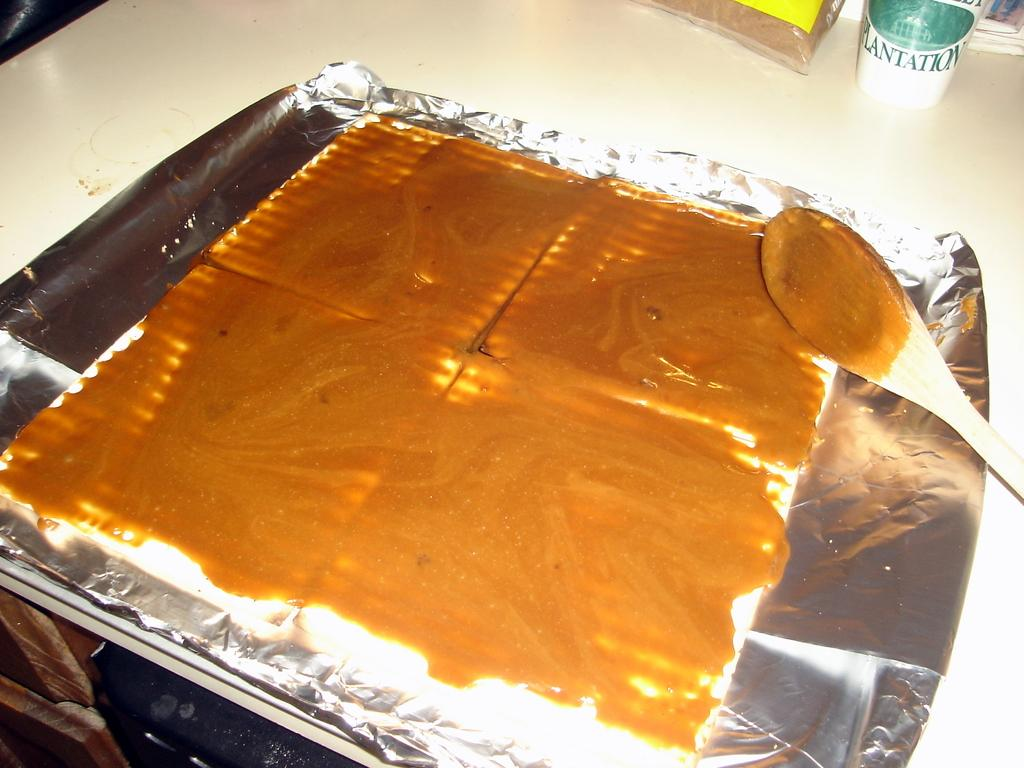Provide a one-sentence caption for the provided image. A cup with the word Plantation on it is on the back of a table behind some tinfoil. 